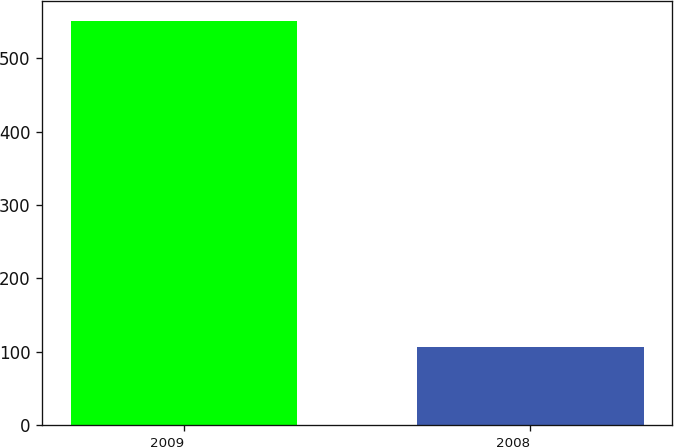Convert chart to OTSL. <chart><loc_0><loc_0><loc_500><loc_500><bar_chart><fcel>2009<fcel>2008<nl><fcel>550<fcel>106<nl></chart> 